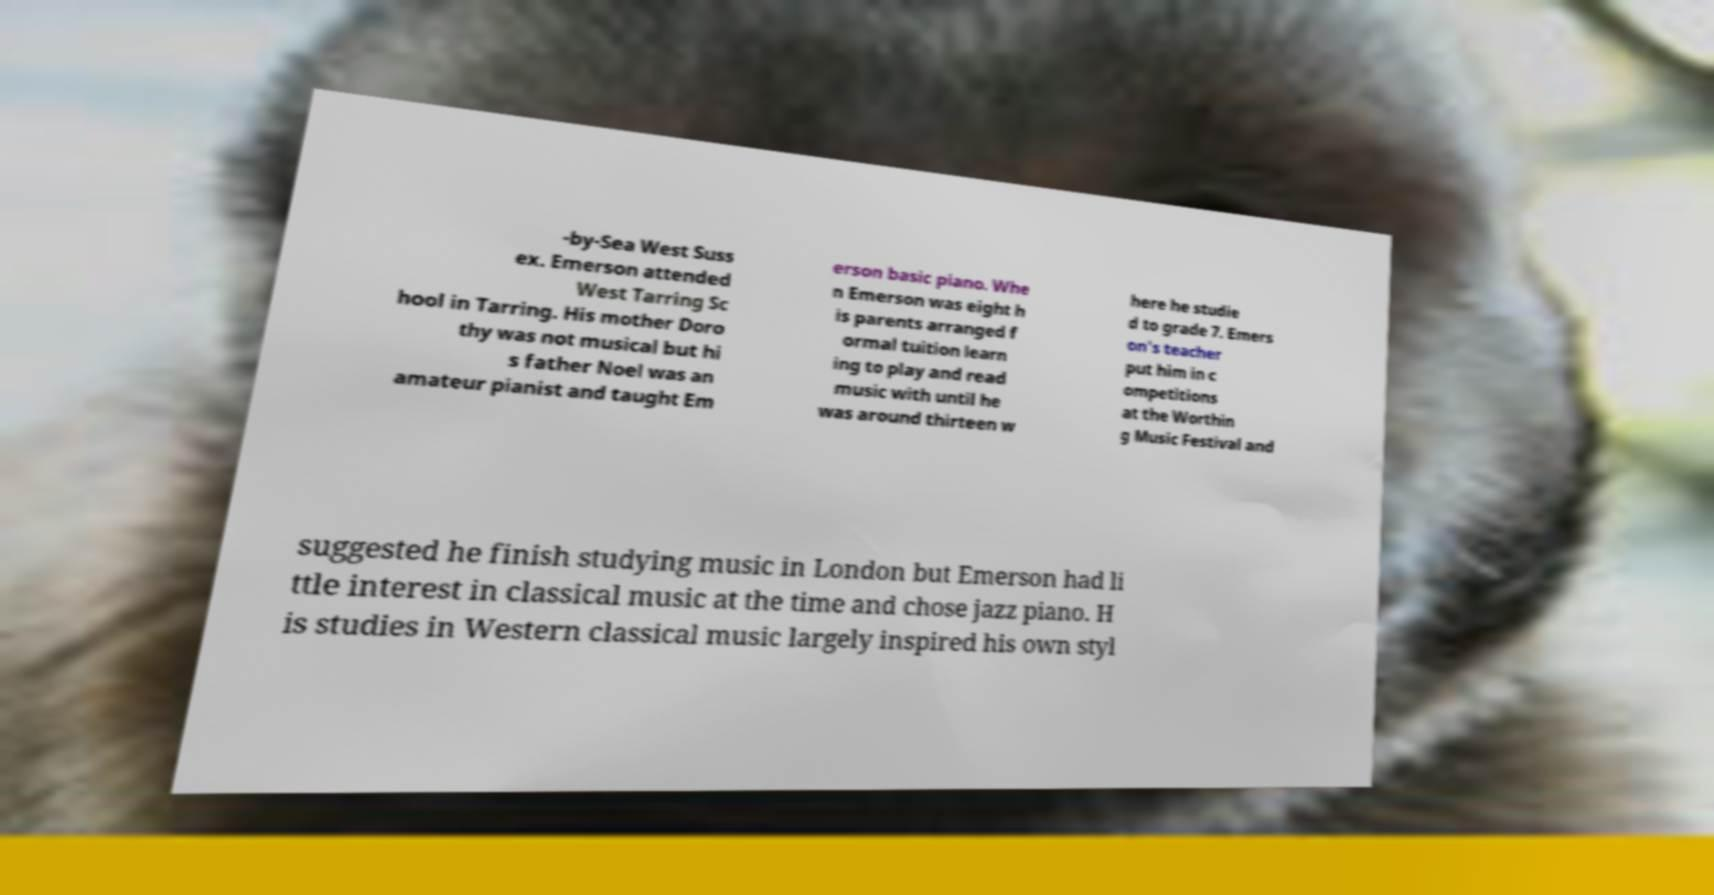Could you extract and type out the text from this image? -by-Sea West Suss ex. Emerson attended West Tarring Sc hool in Tarring. His mother Doro thy was not musical but hi s father Noel was an amateur pianist and taught Em erson basic piano. Whe n Emerson was eight h is parents arranged f ormal tuition learn ing to play and read music with until he was around thirteen w here he studie d to grade 7. Emers on's teacher put him in c ompetitions at the Worthin g Music Festival and suggested he finish studying music in London but Emerson had li ttle interest in classical music at the time and chose jazz piano. H is studies in Western classical music largely inspired his own styl 